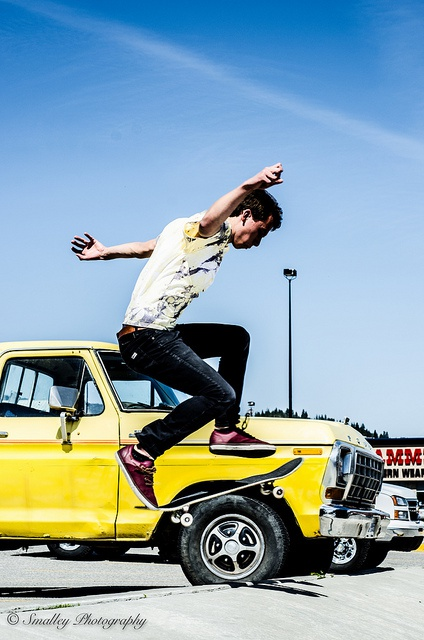Describe the objects in this image and their specific colors. I can see truck in gray, black, gold, beige, and khaki tones, people in gray, black, white, lightblue, and maroon tones, truck in gray, black, lightgray, and darkgray tones, and skateboard in gray, black, ivory, and darkgray tones in this image. 